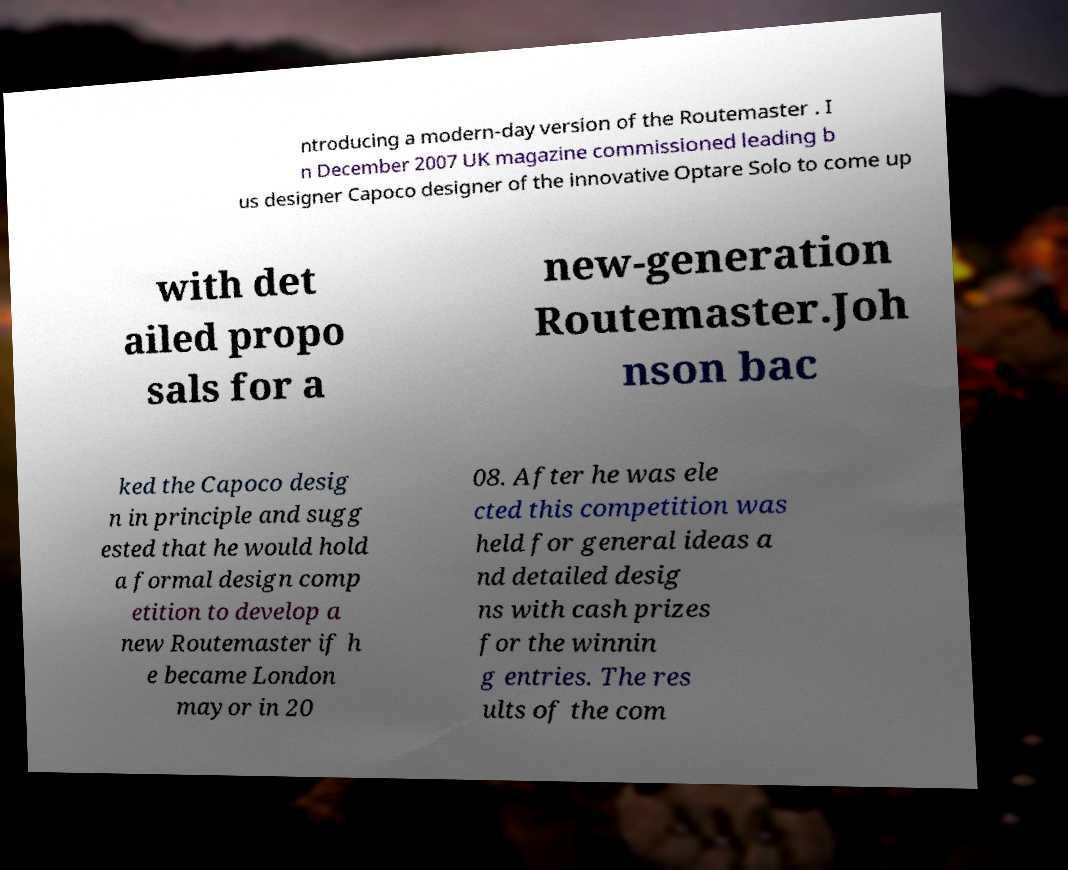I need the written content from this picture converted into text. Can you do that? ntroducing a modern-day version of the Routemaster . I n December 2007 UK magazine commissioned leading b us designer Capoco designer of the innovative Optare Solo to come up with det ailed propo sals for a new-generation Routemaster.Joh nson bac ked the Capoco desig n in principle and sugg ested that he would hold a formal design comp etition to develop a new Routemaster if h e became London mayor in 20 08. After he was ele cted this competition was held for general ideas a nd detailed desig ns with cash prizes for the winnin g entries. The res ults of the com 